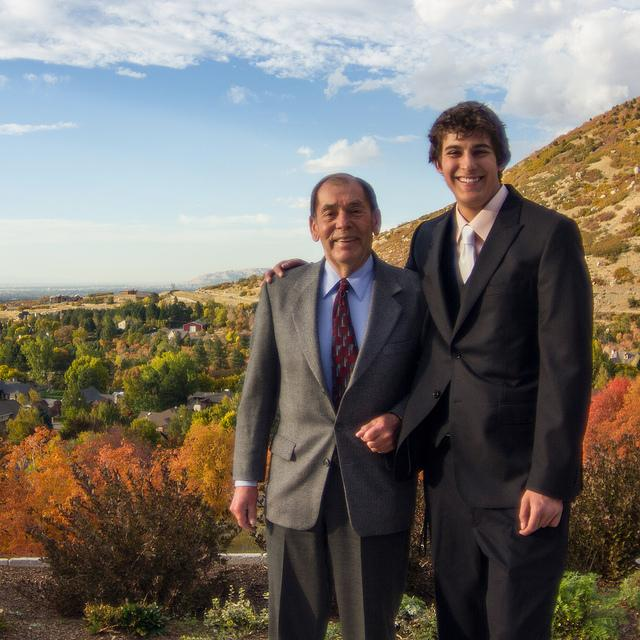What type setting do these men pose in? Please explain your reasoning. farm. The men are posing in a scene filled with natural landscape and farmland. 